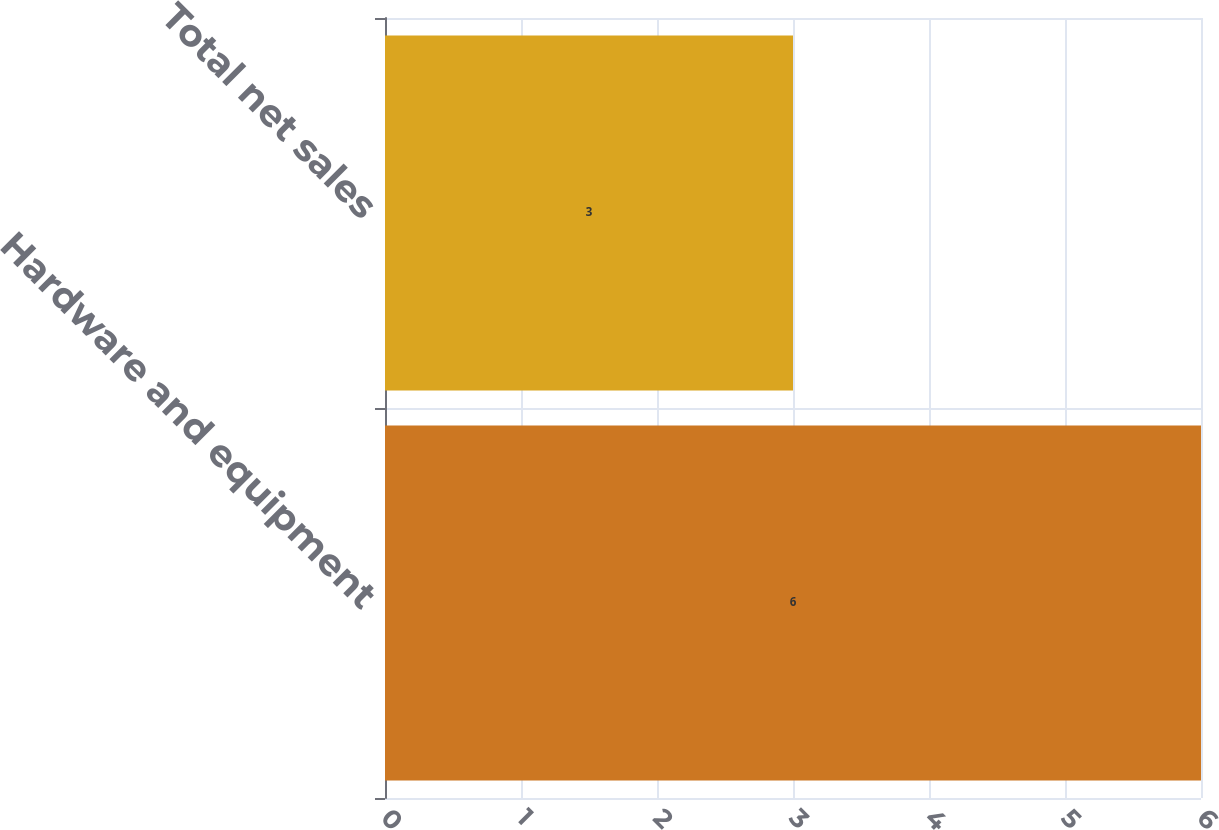Convert chart. <chart><loc_0><loc_0><loc_500><loc_500><bar_chart><fcel>Hardware and equipment<fcel>Total net sales<nl><fcel>6<fcel>3<nl></chart> 